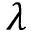<formula> <loc_0><loc_0><loc_500><loc_500>\lambda</formula> 